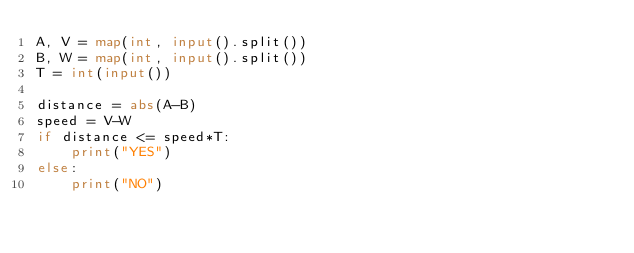Convert code to text. <code><loc_0><loc_0><loc_500><loc_500><_Python_>A, V = map(int, input().split())
B, W = map(int, input().split())
T = int(input())

distance = abs(A-B)
speed = V-W
if distance <= speed*T:
    print("YES")
else:
    print("NO")
</code> 